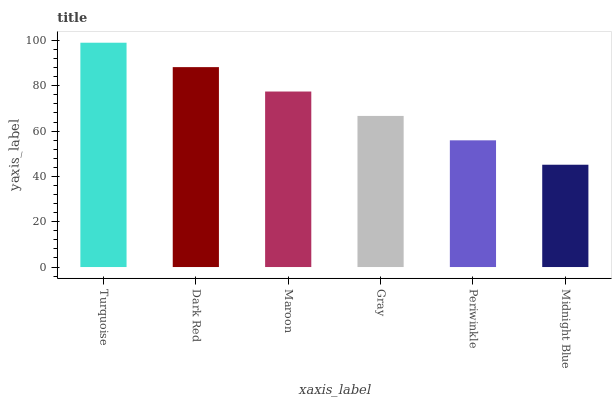Is Midnight Blue the minimum?
Answer yes or no. Yes. Is Turquoise the maximum?
Answer yes or no. Yes. Is Dark Red the minimum?
Answer yes or no. No. Is Dark Red the maximum?
Answer yes or no. No. Is Turquoise greater than Dark Red?
Answer yes or no. Yes. Is Dark Red less than Turquoise?
Answer yes or no. Yes. Is Dark Red greater than Turquoise?
Answer yes or no. No. Is Turquoise less than Dark Red?
Answer yes or no. No. Is Maroon the high median?
Answer yes or no. Yes. Is Gray the low median?
Answer yes or no. Yes. Is Periwinkle the high median?
Answer yes or no. No. Is Maroon the low median?
Answer yes or no. No. 